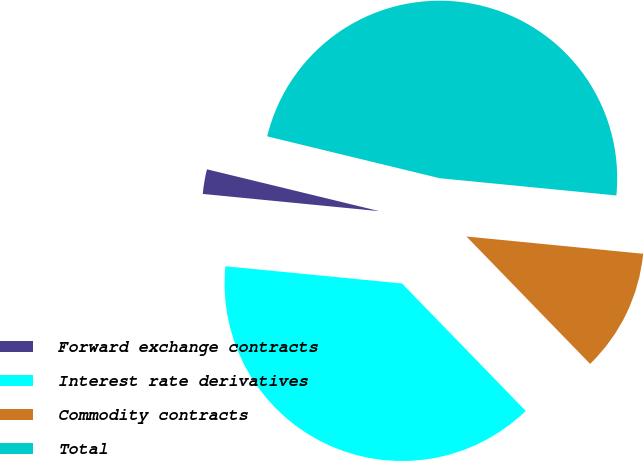<chart> <loc_0><loc_0><loc_500><loc_500><pie_chart><fcel>Forward exchange contracts<fcel>Interest rate derivatives<fcel>Commodity contracts<fcel>Total<nl><fcel>2.24%<fcel>38.81%<fcel>11.19%<fcel>47.76%<nl></chart> 